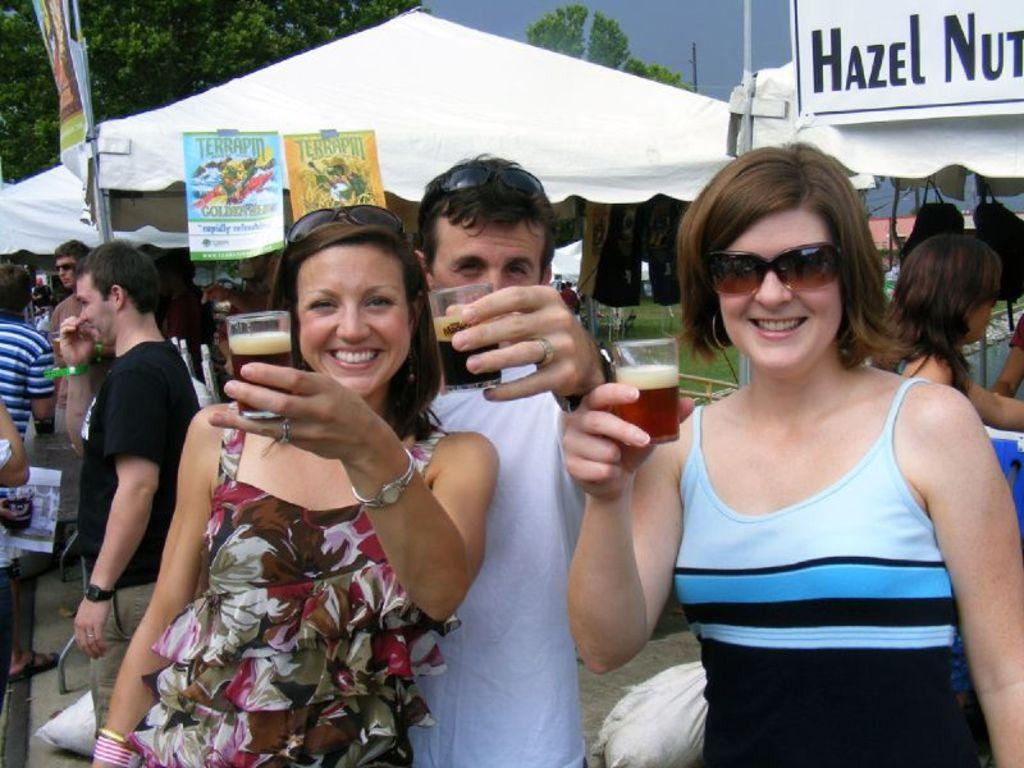What are the persons in the image doing? The persons in the image are standing on the ground. What objects are the persons holding? The persons are holding glass tumblers. What can be seen in the background of the image? There are advertisements, tents, trees, and the sky visible in the background. What type of jeans are the persons wearing in the image? There is no information about the type of jeans the persons are wearing in the image, as the provided facts do not mention clothing. 